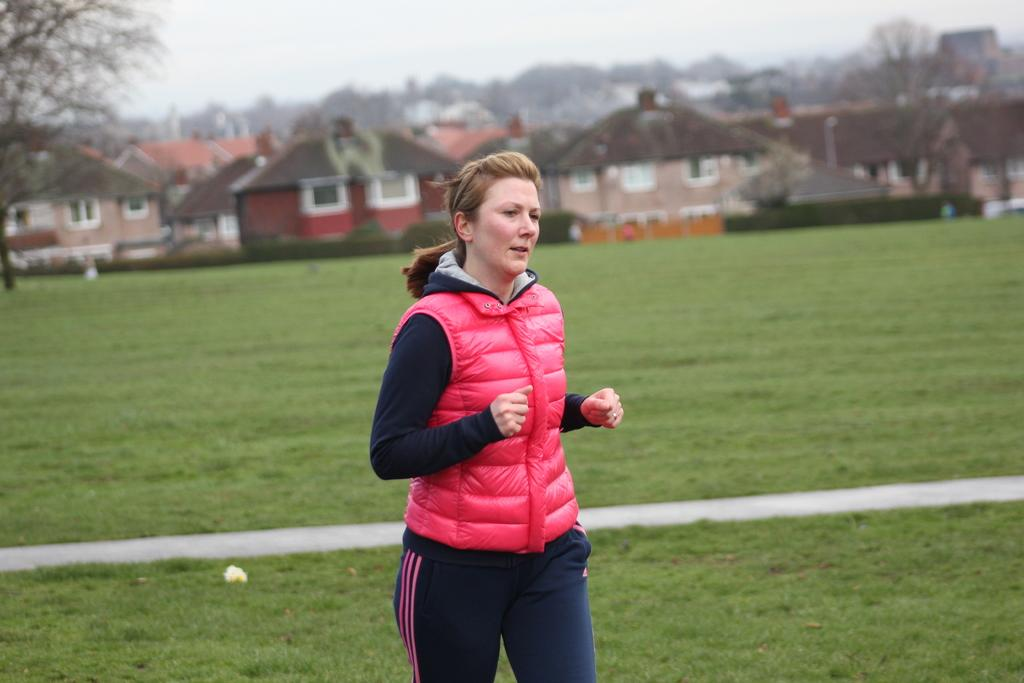What is the main subject of the image? There is a woman standing in the image. What type of terrain is visible in the image? There is grass in the image. What can be seen in the background of the image? There are houses and trees in the background of the image. What is visible in the sky in the image? The sky is visible in the background of the image. What type of vest is the woman wearing in the image? The image does not show the woman wearing a vest, so it cannot be determined from the image. 